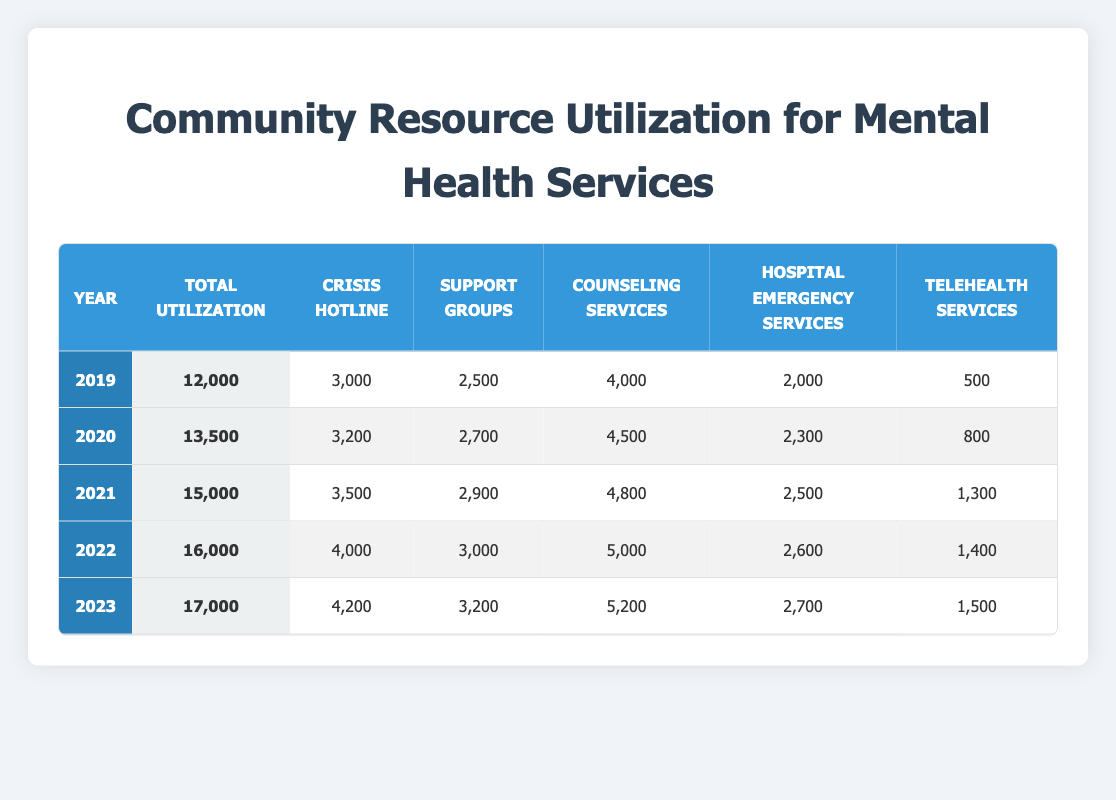What was the total utilization of mental health services in 2020? In the table, I can find the row for the year 2020 and the corresponding value for total utilization, which is listed as 13500.
Answer: 13500 Which year had the highest number of counseling services utilized? By examining the 'Counseling Services' column in the table, I can see the values for each year: 4000 for 2019, 4500 for 2020, 4800 for 2021, 5000 for 2022, and 5200 for 2023. The highest number is 5200 in 2023.
Answer: 2023 Is the total utilization of mental health services in 2021 greater than that in 2019? I can check the total utilization for both years: 15000 for 2021 and 12000 for 2019. Since 15000 is greater than 12000, the statement is true.
Answer: Yes What is the percentage increase in crisis hotline utilization from 2020 to 2022? For these years, the crisis hotline utilization values are 3200 for 2020 and 4000 for 2022. The increase is 4000 - 3200 = 800. To find the percentage increase, I calculate (800 / 3200) * 100 = 25%.
Answer: 25% What was the average utilization of telehealth services over the five years? The telehealth services utilization values are 500, 800, 1300, 1400, and 1500. First, I add these values: 500 + 800 + 1300 + 1400 + 1500 = 4500. Then, I divide by the number of years, which is 5: 4500 / 5 = 900.
Answer: 900 Which services saw an increase in utilization from 2021 to 2023? In this case, I will look at the specific service columns from 2021 to 2023: Crisis Hotline (3500 to 4200), Support Groups (2900 to 3200), Counseling Services (4800 to 5200), Hospital Emergency Services (2500 to 2700), and Telehealth Services (1300 to 1500). All these services increased in utilization.
Answer: All services What is the difference in total utilization between the years 2019 and 2023? For 2019, the total utilization is 12000, and for 2023 it is 17000. The difference is 17000 - 12000 = 5000.
Answer: 5000 Did the utilization of support groups decline in any year from 2019 to 2023? I can check the values for support groups across the years: 2500 in 2019, 2700 in 2020, 2900 in 2021, 3000 in 2022, and 3200 in 2023. Since there are no declines, the statement is false.
Answer: No 